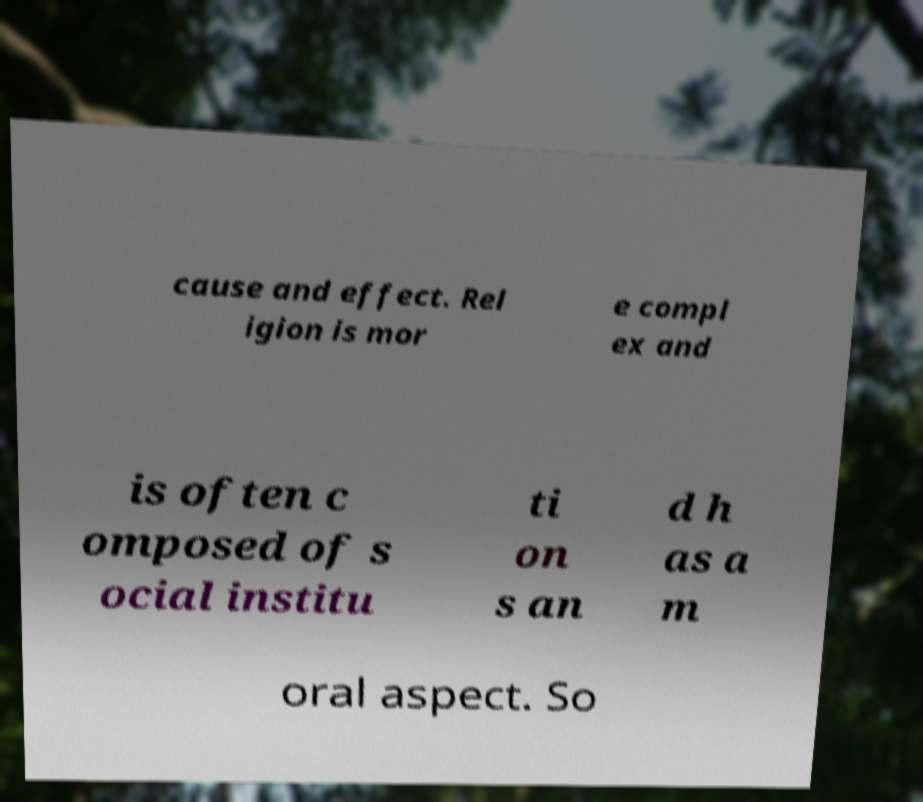Please identify and transcribe the text found in this image. cause and effect. Rel igion is mor e compl ex and is often c omposed of s ocial institu ti on s an d h as a m oral aspect. So 